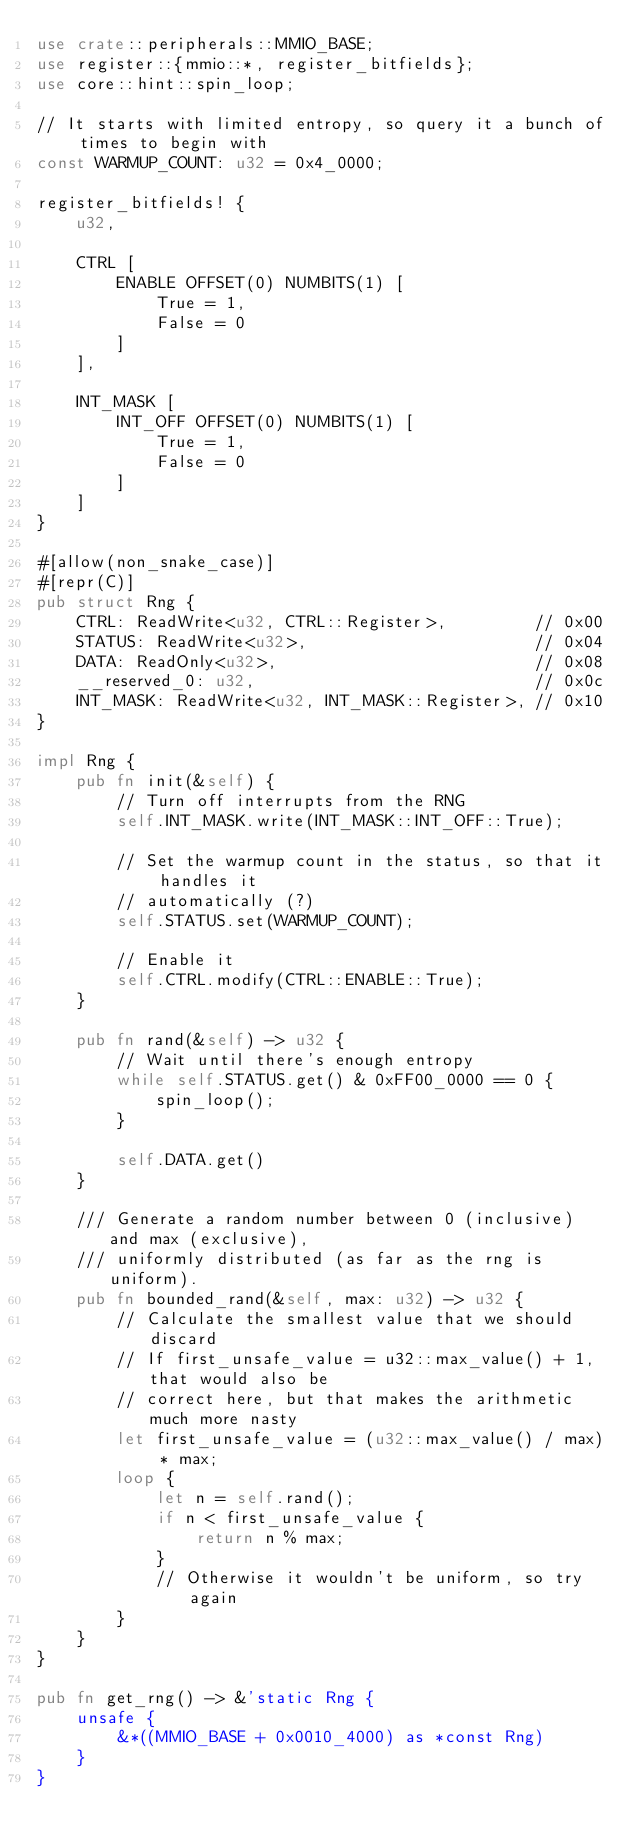<code> <loc_0><loc_0><loc_500><loc_500><_Rust_>use crate::peripherals::MMIO_BASE;
use register::{mmio::*, register_bitfields};
use core::hint::spin_loop;

// It starts with limited entropy, so query it a bunch of times to begin with
const WARMUP_COUNT: u32 = 0x4_0000;

register_bitfields! {
    u32,

    CTRL [
        ENABLE OFFSET(0) NUMBITS(1) [
            True = 1,
            False = 0
        ]
    ],

    INT_MASK [
        INT_OFF OFFSET(0) NUMBITS(1) [
            True = 1,
            False = 0
        ]
    ]
}

#[allow(non_snake_case)]
#[repr(C)]
pub struct Rng {
    CTRL: ReadWrite<u32, CTRL::Register>,         // 0x00
    STATUS: ReadWrite<u32>,                       // 0x04
    DATA: ReadOnly<u32>,                          // 0x08
    __reserved_0: u32,                            // 0x0c
    INT_MASK: ReadWrite<u32, INT_MASK::Register>, // 0x10
}

impl Rng {
    pub fn init(&self) {
        // Turn off interrupts from the RNG
        self.INT_MASK.write(INT_MASK::INT_OFF::True);

        // Set the warmup count in the status, so that it handles it
        // automatically (?)
        self.STATUS.set(WARMUP_COUNT);

        // Enable it
        self.CTRL.modify(CTRL::ENABLE::True);
    }

    pub fn rand(&self) -> u32 {
        // Wait until there's enough entropy
        while self.STATUS.get() & 0xFF00_0000 == 0 {
            spin_loop();
        }

        self.DATA.get()
    }

    /// Generate a random number between 0 (inclusive) and max (exclusive),
    /// uniformly distributed (as far as the rng is uniform).
    pub fn bounded_rand(&self, max: u32) -> u32 {
        // Calculate the smallest value that we should discard
        // If first_unsafe_value = u32::max_value() + 1, that would also be
        // correct here, but that makes the arithmetic much more nasty
        let first_unsafe_value = (u32::max_value() / max) * max;
        loop {
            let n = self.rand();
            if n < first_unsafe_value {
                return n % max;
            }
            // Otherwise it wouldn't be uniform, so try again
        }
    }
}

pub fn get_rng() -> &'static Rng {
    unsafe {
        &*((MMIO_BASE + 0x0010_4000) as *const Rng)
    }
}
</code> 